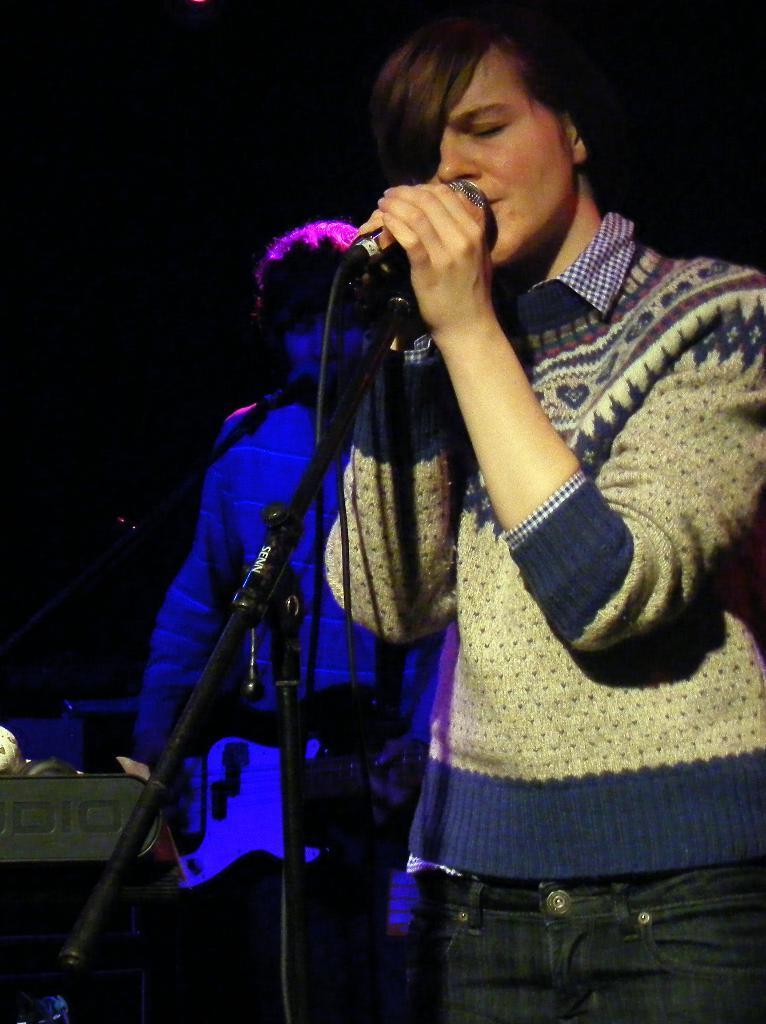Can you describe this image briefly? Here in this picture, in the front we can see a person standing over a place and singing a song in the microphone present in front of him and behind him we can see another person playing guitar present in his hands. 